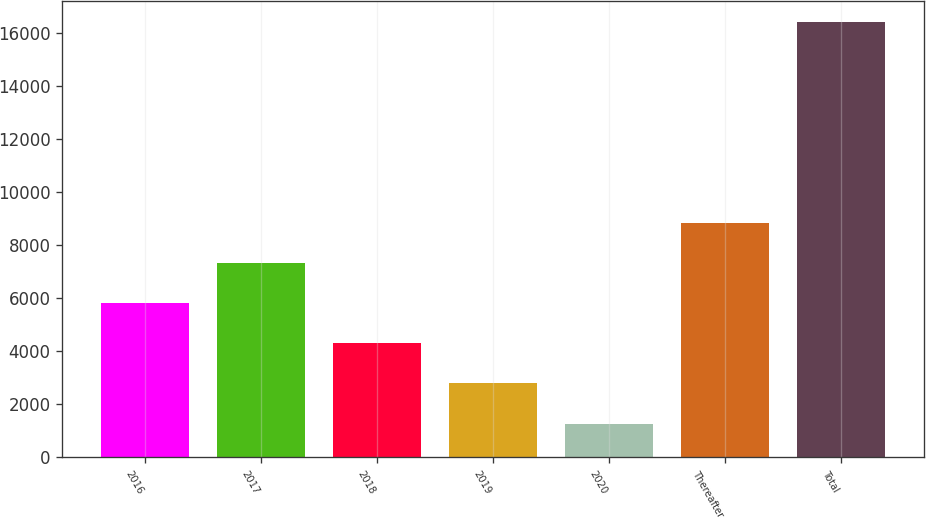Convert chart to OTSL. <chart><loc_0><loc_0><loc_500><loc_500><bar_chart><fcel>2016<fcel>2017<fcel>2018<fcel>2019<fcel>2020<fcel>Thereafter<fcel>Total<nl><fcel>5801<fcel>7313<fcel>4289<fcel>2777<fcel>1265<fcel>8825<fcel>16385<nl></chart> 